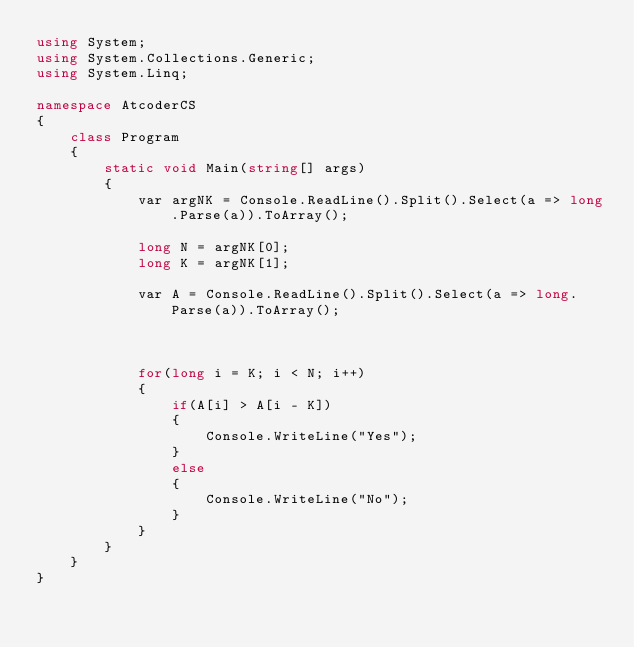Convert code to text. <code><loc_0><loc_0><loc_500><loc_500><_C#_>using System;
using System.Collections.Generic;
using System.Linq;

namespace AtcoderCS
{
    class Program
    {
        static void Main(string[] args)
        {
            var argNK = Console.ReadLine().Split().Select(a => long.Parse(a)).ToArray();

            long N = argNK[0];
            long K = argNK[1];

            var A = Console.ReadLine().Split().Select(a => long.Parse(a)).ToArray();

            

            for(long i = K; i < N; i++)
            {
                if(A[i] > A[i - K])
                {
                    Console.WriteLine("Yes");
                }
                else
                {
                    Console.WriteLine("No");
                }
            }
        }
    }
}
</code> 